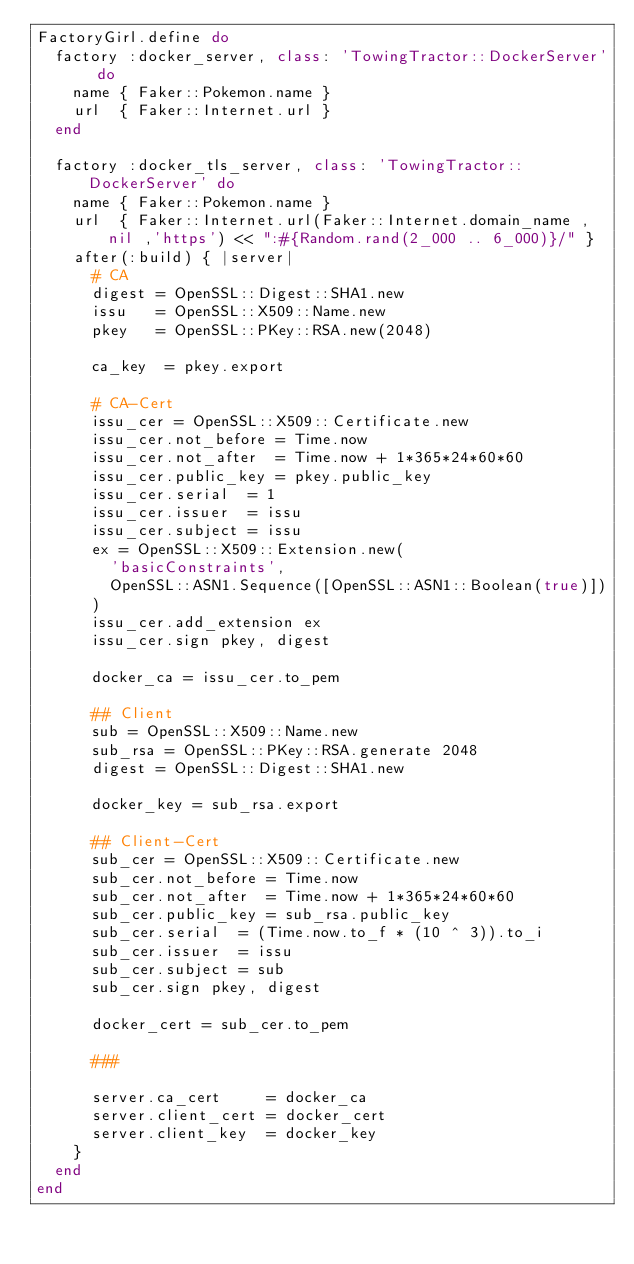<code> <loc_0><loc_0><loc_500><loc_500><_Ruby_>FactoryGirl.define do
  factory :docker_server, class: 'TowingTractor::DockerServer' do
    name { Faker::Pokemon.name }
    url  { Faker::Internet.url }
  end

  factory :docker_tls_server, class: 'TowingTractor::DockerServer' do
    name { Faker::Pokemon.name }
    url  { Faker::Internet.url(Faker::Internet.domain_name ,nil ,'https') << ":#{Random.rand(2_000 .. 6_000)}/" }
    after(:build) { |server|
      # CA
      digest = OpenSSL::Digest::SHA1.new
      issu   = OpenSSL::X509::Name.new
      pkey   = OpenSSL::PKey::RSA.new(2048)

      ca_key  = pkey.export

      # CA-Cert
      issu_cer = OpenSSL::X509::Certificate.new
      issu_cer.not_before = Time.now
      issu_cer.not_after  = Time.now + 1*365*24*60*60
      issu_cer.public_key = pkey.public_key
      issu_cer.serial  = 1
      issu_cer.issuer  = issu
      issu_cer.subject = issu
      ex = OpenSSL::X509::Extension.new(
        'basicConstraints',
        OpenSSL::ASN1.Sequence([OpenSSL::ASN1::Boolean(true)])
      )
      issu_cer.add_extension ex
      issu_cer.sign pkey, digest

      docker_ca = issu_cer.to_pem

      ## Client
      sub = OpenSSL::X509::Name.new
      sub_rsa = OpenSSL::PKey::RSA.generate 2048
      digest = OpenSSL::Digest::SHA1.new

      docker_key = sub_rsa.export

      ## Client-Cert
      sub_cer = OpenSSL::X509::Certificate.new
      sub_cer.not_before = Time.now
      sub_cer.not_after  = Time.now + 1*365*24*60*60
      sub_cer.public_key = sub_rsa.public_key
      sub_cer.serial  = (Time.now.to_f * (10 ^ 3)).to_i
      sub_cer.issuer  = issu
      sub_cer.subject = sub
      sub_cer.sign pkey, digest

      docker_cert = sub_cer.to_pem

      ###

      server.ca_cert     = docker_ca
      server.client_cert = docker_cert
      server.client_key  = docker_key
    }
  end
end
</code> 